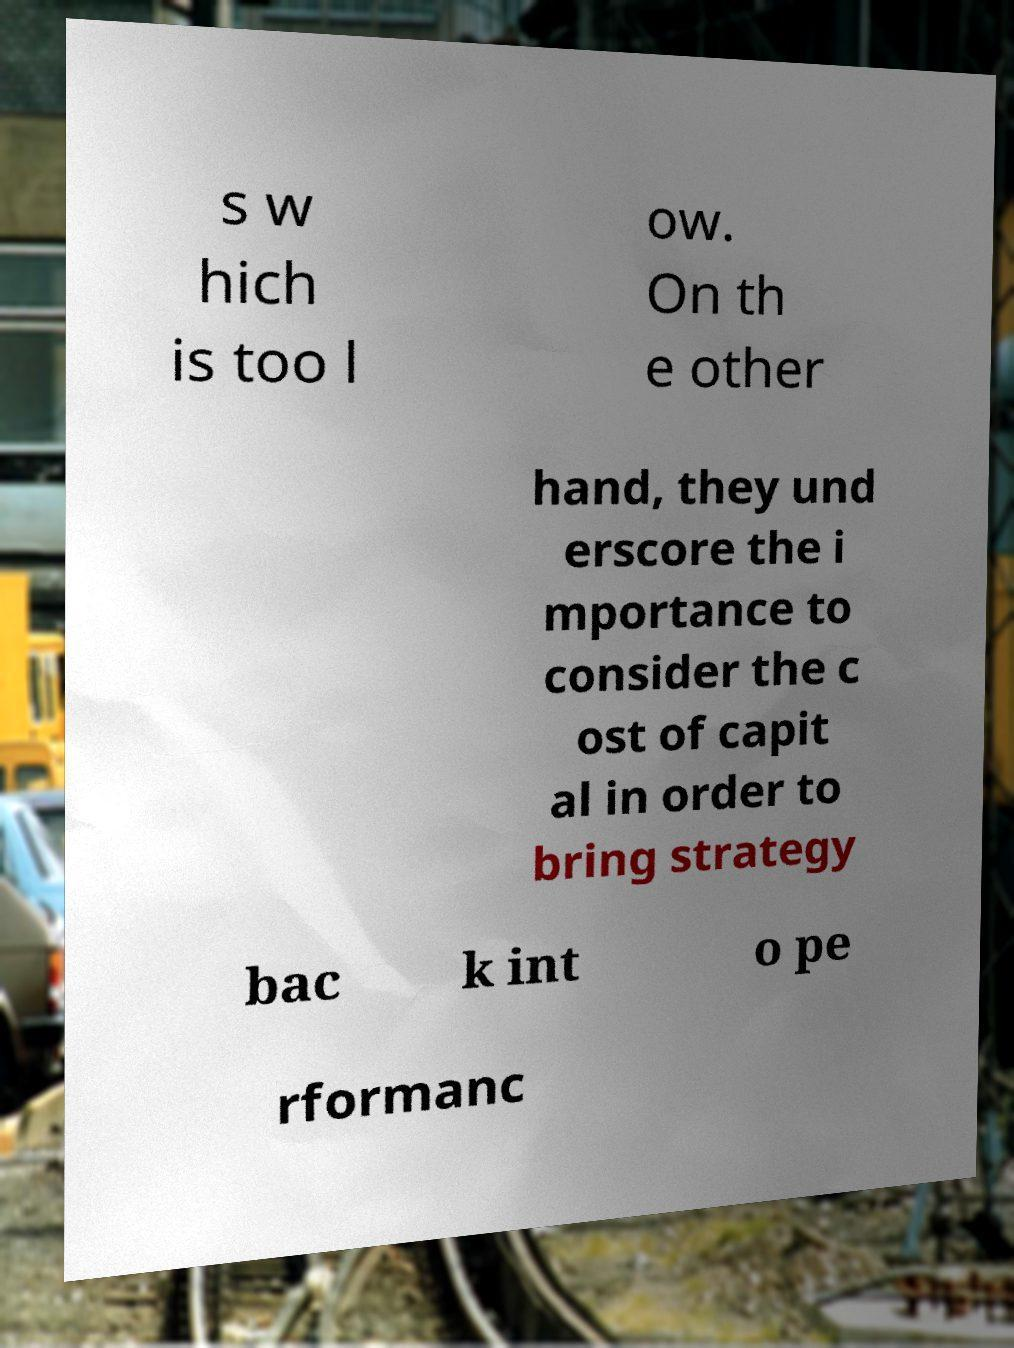I need the written content from this picture converted into text. Can you do that? s w hich is too l ow. On th e other hand, they und erscore the i mportance to consider the c ost of capit al in order to bring strategy bac k int o pe rformanc 